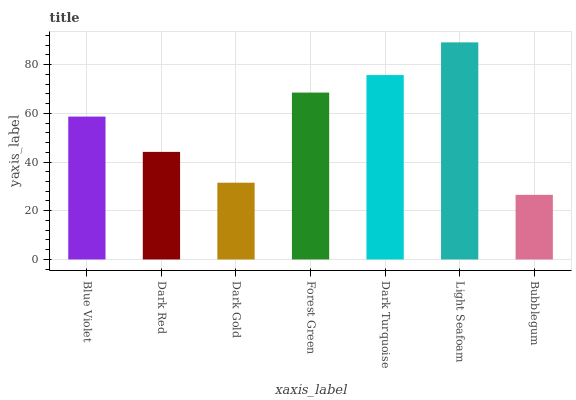Is Bubblegum the minimum?
Answer yes or no. Yes. Is Light Seafoam the maximum?
Answer yes or no. Yes. Is Dark Red the minimum?
Answer yes or no. No. Is Dark Red the maximum?
Answer yes or no. No. Is Blue Violet greater than Dark Red?
Answer yes or no. Yes. Is Dark Red less than Blue Violet?
Answer yes or no. Yes. Is Dark Red greater than Blue Violet?
Answer yes or no. No. Is Blue Violet less than Dark Red?
Answer yes or no. No. Is Blue Violet the high median?
Answer yes or no. Yes. Is Blue Violet the low median?
Answer yes or no. Yes. Is Bubblegum the high median?
Answer yes or no. No. Is Light Seafoam the low median?
Answer yes or no. No. 